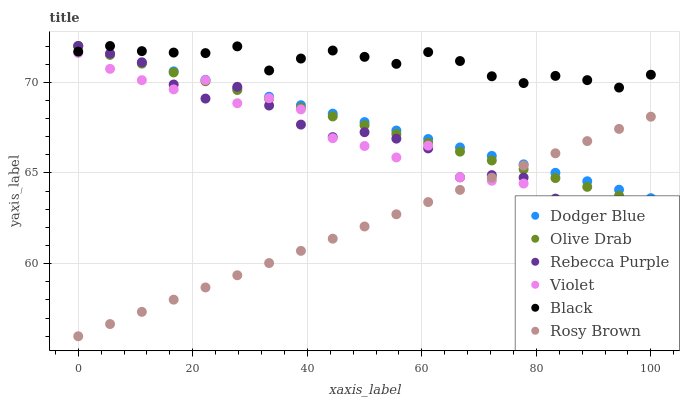Does Rosy Brown have the minimum area under the curve?
Answer yes or no. Yes. Does Black have the maximum area under the curve?
Answer yes or no. Yes. Does Rebecca Purple have the minimum area under the curve?
Answer yes or no. No. Does Rebecca Purple have the maximum area under the curve?
Answer yes or no. No. Is Olive Drab the smoothest?
Answer yes or no. Yes. Is Violet the roughest?
Answer yes or no. Yes. Is Black the smoothest?
Answer yes or no. No. Is Black the roughest?
Answer yes or no. No. Does Rosy Brown have the lowest value?
Answer yes or no. Yes. Does Rebecca Purple have the lowest value?
Answer yes or no. No. Does Olive Drab have the highest value?
Answer yes or no. Yes. Does Violet have the highest value?
Answer yes or no. No. Is Violet less than Dodger Blue?
Answer yes or no. Yes. Is Black greater than Violet?
Answer yes or no. Yes. Does Olive Drab intersect Dodger Blue?
Answer yes or no. Yes. Is Olive Drab less than Dodger Blue?
Answer yes or no. No. Is Olive Drab greater than Dodger Blue?
Answer yes or no. No. Does Violet intersect Dodger Blue?
Answer yes or no. No. 